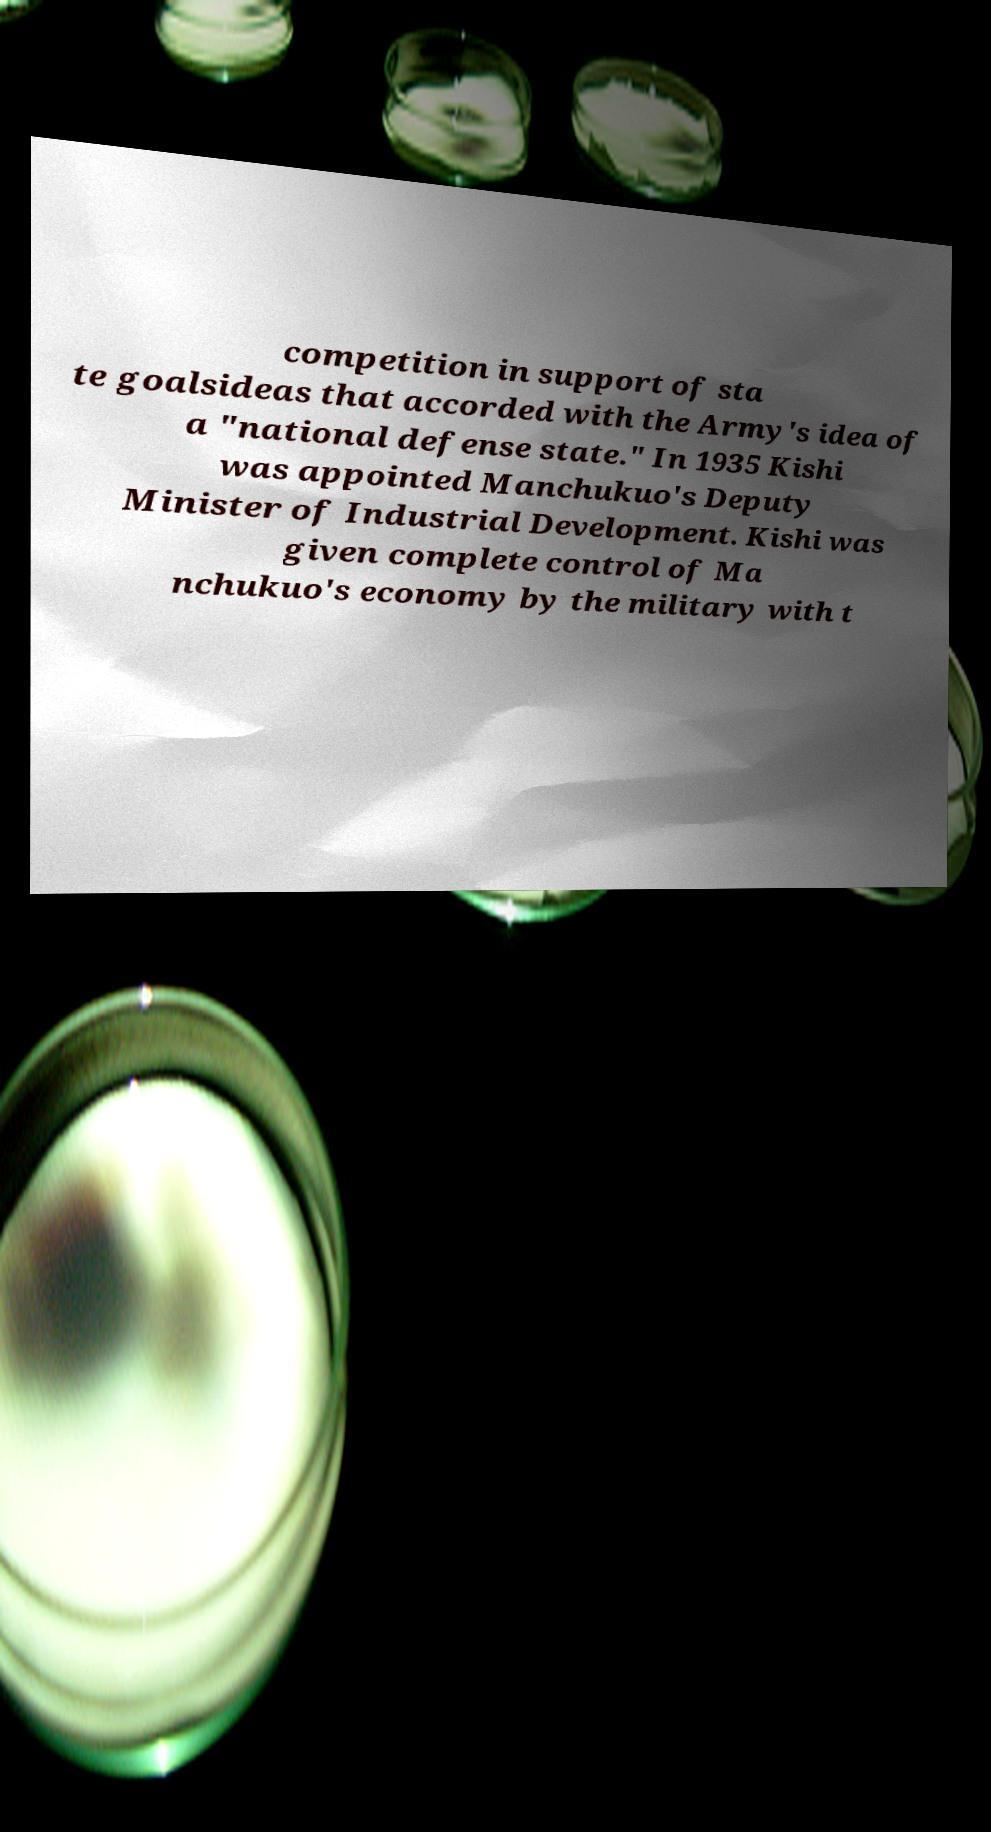For documentation purposes, I need the text within this image transcribed. Could you provide that? competition in support of sta te goalsideas that accorded with the Army's idea of a "national defense state." In 1935 Kishi was appointed Manchukuo's Deputy Minister of Industrial Development. Kishi was given complete control of Ma nchukuo's economy by the military with t 